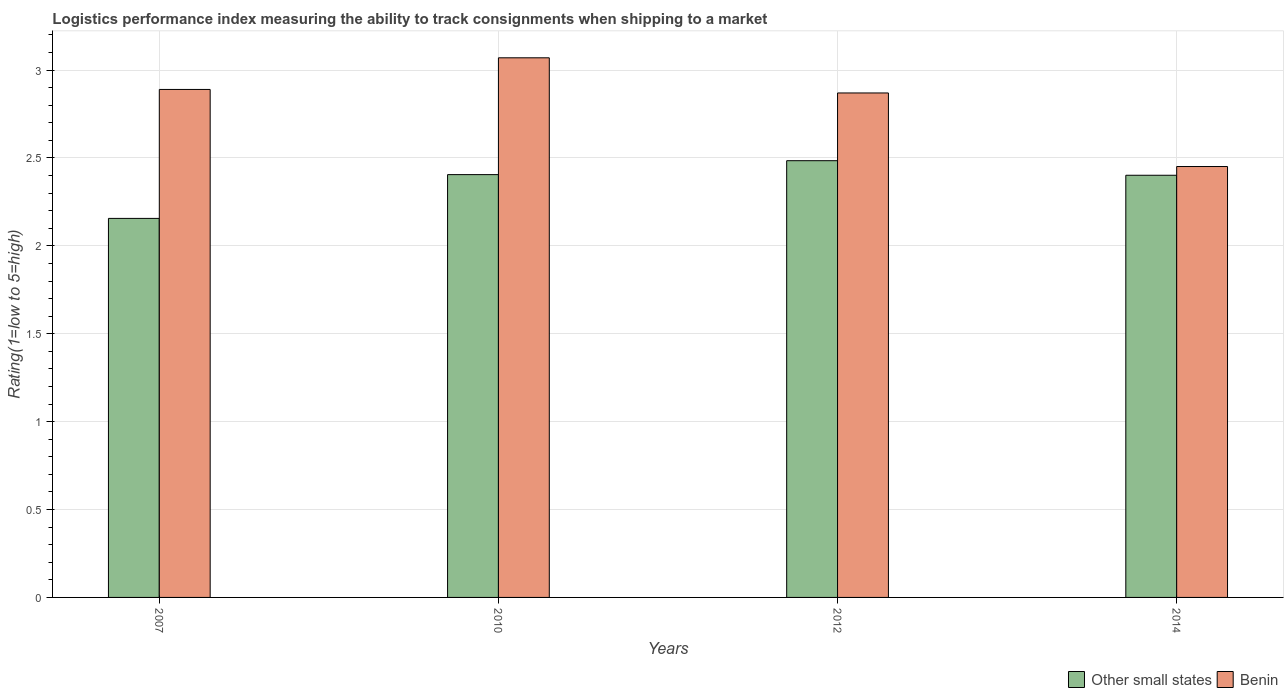How many different coloured bars are there?
Provide a succinct answer. 2. How many groups of bars are there?
Offer a terse response. 4. Are the number of bars per tick equal to the number of legend labels?
Keep it short and to the point. Yes. Are the number of bars on each tick of the X-axis equal?
Make the answer very short. Yes. How many bars are there on the 3rd tick from the left?
Keep it short and to the point. 2. How many bars are there on the 3rd tick from the right?
Your response must be concise. 2. What is the label of the 3rd group of bars from the left?
Make the answer very short. 2012. In how many cases, is the number of bars for a given year not equal to the number of legend labels?
Your answer should be very brief. 0. What is the Logistic performance index in Other small states in 2012?
Offer a terse response. 2.48. Across all years, what is the maximum Logistic performance index in Benin?
Give a very brief answer. 3.07. Across all years, what is the minimum Logistic performance index in Other small states?
Make the answer very short. 2.16. In which year was the Logistic performance index in Other small states maximum?
Make the answer very short. 2012. In which year was the Logistic performance index in Benin minimum?
Provide a short and direct response. 2014. What is the total Logistic performance index in Other small states in the graph?
Keep it short and to the point. 9.45. What is the difference between the Logistic performance index in Benin in 2007 and that in 2012?
Provide a short and direct response. 0.02. What is the difference between the Logistic performance index in Benin in 2007 and the Logistic performance index in Other small states in 2012?
Your answer should be very brief. 0.41. What is the average Logistic performance index in Other small states per year?
Offer a very short reply. 2.36. In the year 2007, what is the difference between the Logistic performance index in Other small states and Logistic performance index in Benin?
Ensure brevity in your answer.  -0.73. In how many years, is the Logistic performance index in Other small states greater than 0.7?
Provide a succinct answer. 4. What is the ratio of the Logistic performance index in Benin in 2010 to that in 2012?
Your answer should be compact. 1.07. What is the difference between the highest and the second highest Logistic performance index in Benin?
Give a very brief answer. 0.18. What is the difference between the highest and the lowest Logistic performance index in Benin?
Your response must be concise. 0.62. In how many years, is the Logistic performance index in Benin greater than the average Logistic performance index in Benin taken over all years?
Offer a very short reply. 3. What does the 1st bar from the left in 2014 represents?
Your response must be concise. Other small states. What does the 1st bar from the right in 2010 represents?
Provide a succinct answer. Benin. How many bars are there?
Provide a short and direct response. 8. Are all the bars in the graph horizontal?
Your answer should be very brief. No. What is the difference between two consecutive major ticks on the Y-axis?
Make the answer very short. 0.5. Does the graph contain grids?
Offer a terse response. Yes. Where does the legend appear in the graph?
Ensure brevity in your answer.  Bottom right. How are the legend labels stacked?
Your answer should be compact. Horizontal. What is the title of the graph?
Make the answer very short. Logistics performance index measuring the ability to track consignments when shipping to a market. What is the label or title of the X-axis?
Make the answer very short. Years. What is the label or title of the Y-axis?
Give a very brief answer. Rating(1=low to 5=high). What is the Rating(1=low to 5=high) in Other small states in 2007?
Offer a very short reply. 2.16. What is the Rating(1=low to 5=high) of Benin in 2007?
Your answer should be very brief. 2.89. What is the Rating(1=low to 5=high) of Other small states in 2010?
Offer a terse response. 2.41. What is the Rating(1=low to 5=high) of Benin in 2010?
Offer a very short reply. 3.07. What is the Rating(1=low to 5=high) in Other small states in 2012?
Your answer should be compact. 2.48. What is the Rating(1=low to 5=high) of Benin in 2012?
Your answer should be compact. 2.87. What is the Rating(1=low to 5=high) in Other small states in 2014?
Offer a terse response. 2.4. What is the Rating(1=low to 5=high) of Benin in 2014?
Offer a very short reply. 2.45. Across all years, what is the maximum Rating(1=low to 5=high) in Other small states?
Provide a succinct answer. 2.48. Across all years, what is the maximum Rating(1=low to 5=high) of Benin?
Offer a very short reply. 3.07. Across all years, what is the minimum Rating(1=low to 5=high) in Other small states?
Your answer should be very brief. 2.16. Across all years, what is the minimum Rating(1=low to 5=high) of Benin?
Ensure brevity in your answer.  2.45. What is the total Rating(1=low to 5=high) in Other small states in the graph?
Make the answer very short. 9.45. What is the total Rating(1=low to 5=high) of Benin in the graph?
Provide a short and direct response. 11.28. What is the difference between the Rating(1=low to 5=high) in Other small states in 2007 and that in 2010?
Your response must be concise. -0.25. What is the difference between the Rating(1=low to 5=high) of Benin in 2007 and that in 2010?
Give a very brief answer. -0.18. What is the difference between the Rating(1=low to 5=high) in Other small states in 2007 and that in 2012?
Your answer should be compact. -0.33. What is the difference between the Rating(1=low to 5=high) in Other small states in 2007 and that in 2014?
Offer a terse response. -0.25. What is the difference between the Rating(1=low to 5=high) in Benin in 2007 and that in 2014?
Make the answer very short. 0.44. What is the difference between the Rating(1=low to 5=high) in Other small states in 2010 and that in 2012?
Your answer should be very brief. -0.08. What is the difference between the Rating(1=low to 5=high) of Benin in 2010 and that in 2012?
Offer a very short reply. 0.2. What is the difference between the Rating(1=low to 5=high) in Other small states in 2010 and that in 2014?
Offer a very short reply. 0. What is the difference between the Rating(1=low to 5=high) in Benin in 2010 and that in 2014?
Ensure brevity in your answer.  0.62. What is the difference between the Rating(1=low to 5=high) of Other small states in 2012 and that in 2014?
Your answer should be compact. 0.08. What is the difference between the Rating(1=low to 5=high) in Benin in 2012 and that in 2014?
Your response must be concise. 0.42. What is the difference between the Rating(1=low to 5=high) of Other small states in 2007 and the Rating(1=low to 5=high) of Benin in 2010?
Give a very brief answer. -0.91. What is the difference between the Rating(1=low to 5=high) in Other small states in 2007 and the Rating(1=low to 5=high) in Benin in 2012?
Provide a succinct answer. -0.71. What is the difference between the Rating(1=low to 5=high) of Other small states in 2007 and the Rating(1=low to 5=high) of Benin in 2014?
Provide a succinct answer. -0.3. What is the difference between the Rating(1=low to 5=high) of Other small states in 2010 and the Rating(1=low to 5=high) of Benin in 2012?
Make the answer very short. -0.46. What is the difference between the Rating(1=low to 5=high) in Other small states in 2010 and the Rating(1=low to 5=high) in Benin in 2014?
Your answer should be compact. -0.05. What is the difference between the Rating(1=low to 5=high) of Other small states in 2012 and the Rating(1=low to 5=high) of Benin in 2014?
Offer a terse response. 0.03. What is the average Rating(1=low to 5=high) of Other small states per year?
Make the answer very short. 2.36. What is the average Rating(1=low to 5=high) in Benin per year?
Offer a terse response. 2.82. In the year 2007, what is the difference between the Rating(1=low to 5=high) in Other small states and Rating(1=low to 5=high) in Benin?
Make the answer very short. -0.73. In the year 2010, what is the difference between the Rating(1=low to 5=high) in Other small states and Rating(1=low to 5=high) in Benin?
Offer a terse response. -0.66. In the year 2012, what is the difference between the Rating(1=low to 5=high) in Other small states and Rating(1=low to 5=high) in Benin?
Offer a terse response. -0.39. In the year 2014, what is the difference between the Rating(1=low to 5=high) in Other small states and Rating(1=low to 5=high) in Benin?
Provide a short and direct response. -0.05. What is the ratio of the Rating(1=low to 5=high) in Other small states in 2007 to that in 2010?
Offer a very short reply. 0.9. What is the ratio of the Rating(1=low to 5=high) in Benin in 2007 to that in 2010?
Give a very brief answer. 0.94. What is the ratio of the Rating(1=low to 5=high) in Other small states in 2007 to that in 2012?
Offer a terse response. 0.87. What is the ratio of the Rating(1=low to 5=high) of Benin in 2007 to that in 2012?
Make the answer very short. 1.01. What is the ratio of the Rating(1=low to 5=high) in Other small states in 2007 to that in 2014?
Provide a short and direct response. 0.9. What is the ratio of the Rating(1=low to 5=high) in Benin in 2007 to that in 2014?
Offer a very short reply. 1.18. What is the ratio of the Rating(1=low to 5=high) of Other small states in 2010 to that in 2012?
Your answer should be very brief. 0.97. What is the ratio of the Rating(1=low to 5=high) of Benin in 2010 to that in 2012?
Your response must be concise. 1.07. What is the ratio of the Rating(1=low to 5=high) of Other small states in 2010 to that in 2014?
Keep it short and to the point. 1. What is the ratio of the Rating(1=low to 5=high) of Benin in 2010 to that in 2014?
Provide a short and direct response. 1.25. What is the ratio of the Rating(1=low to 5=high) in Other small states in 2012 to that in 2014?
Make the answer very short. 1.03. What is the ratio of the Rating(1=low to 5=high) of Benin in 2012 to that in 2014?
Provide a short and direct response. 1.17. What is the difference between the highest and the second highest Rating(1=low to 5=high) of Other small states?
Provide a short and direct response. 0.08. What is the difference between the highest and the second highest Rating(1=low to 5=high) of Benin?
Give a very brief answer. 0.18. What is the difference between the highest and the lowest Rating(1=low to 5=high) of Other small states?
Your response must be concise. 0.33. What is the difference between the highest and the lowest Rating(1=low to 5=high) of Benin?
Your answer should be very brief. 0.62. 